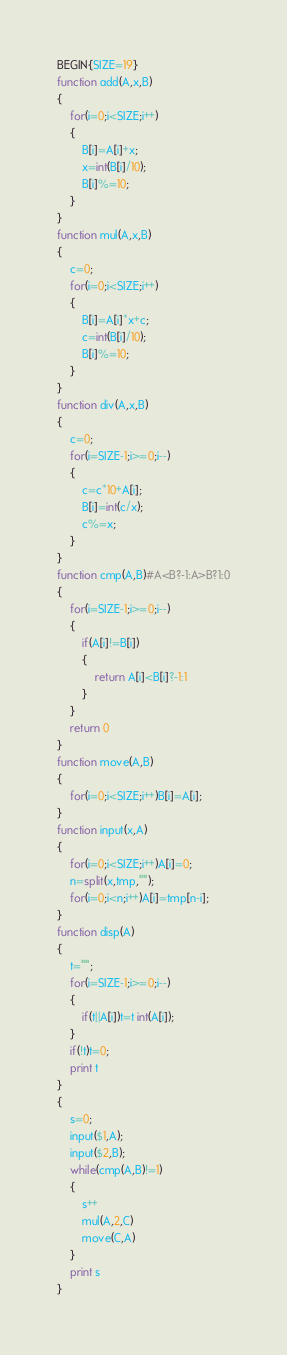<code> <loc_0><loc_0><loc_500><loc_500><_Awk_>BEGIN{SIZE=19}
function add(A,x,B)
{
	for(i=0;i<SIZE;i++)
	{
		B[i]=A[i]+x;
		x=int(B[i]/10);
		B[i]%=10;
	}
}
function mul(A,x,B)
{
	c=0;
	for(i=0;i<SIZE;i++)
	{
		B[i]=A[i]*x+c;
		c=int(B[i]/10);
		B[i]%=10;
	}
}
function div(A,x,B)
{
	c=0;
	for(i=SIZE-1;i>=0;i--)
	{
		c=c*10+A[i];
		B[i]=int(c/x);
		c%=x;
	}
}
function cmp(A,B)#A<B?-1:A>B?1:0
{
	for(i=SIZE-1;i>=0;i--)
	{
		if(A[i]!=B[i])
		{
			return A[i]<B[i]?-1:1
		}
	}
	return 0
}
function move(A,B)
{
	for(i=0;i<SIZE;i++)B[i]=A[i];
}
function input(x,A)
{
	for(i=0;i<SIZE;i++)A[i]=0;
	n=split(x,tmp,"");
	for(i=0;i<n;i++)A[i]=tmp[n-i];
}
function disp(A)
{
	t="";
	for(i=SIZE-1;i>=0;i--)
	{
		if(t||A[i])t=t int(A[i]);
	}
	if(!t)t=0;
	print t
}
{
	s=0;
	input($1,A);
	input($2,B);
	while(cmp(A,B)!=1)
	{
		s++
		mul(A,2,C)
		move(C,A)
	}
	print s
}</code> 